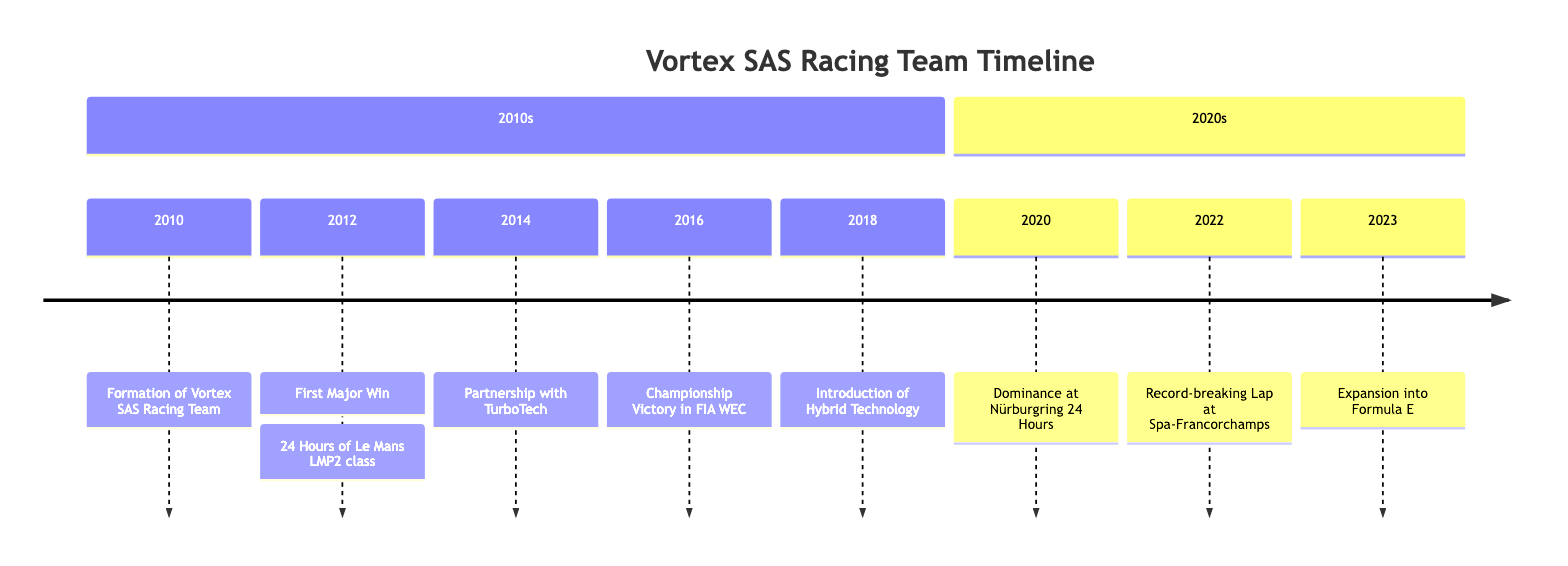What year was Vortex SAS Racing Team formed? The timeline shows the event "Formation of Vortex SAS Racing Team" listed under the year 2010, indicating that this was the year the team was founded.
Answer: 2010 What major win did Vortex SAS achieve in 2012? The timeline states that in 2012, the team secured its "First Major Win" at the "24 Hours of Le Mans in the LMP2 class." This directly identifies the event as their first victory.
Answer: 24 Hours of Le Mans LMP2 class How many major milestones are noted for the year 2016? The timeline indicates that there is one milestone listed for the year 2016, specifically the "Championship Victory in FIA WEC," which reflects a significant achievement during that year.
Answer: 1 What technology did Vortex SAS introduce in 2018? The timeline mentions "Introduction of Hybrid Technology" as the event for the year 2018, indicating that this was when the team incorporated hybrid technology into their cars.
Answer: Hybrid Technology Which year marks the dominance at the Nürburgring 24 Hours? Looking at the timeline, the event titled "Dominance at Nürburgring 24 Hours" is specifically noted under the year 2020, denoting this as the year of their significant achievement at that event.
Answer: 2020 What partnership was announced in 2014? According to the timeline, the event for 2014 is "Partnership with TurboTech," which identifies this specific partnership as a key milestone for that year.
Answer: Partnership with TurboTech Since which year has Vortex SAS expanded into Formula E? The timeline specifies that the team expanded into Formula E in the year 2023, reflecting a new direction for the team's operation in motorsport.
Answer: 2023 How many total events are listed for the 2020s? The timeline details three events in the 2020s section, which include "Dominance at Nürburgring 24 Hours" in 2020, "Record-breaking Lap at Spa-Francorchamps" in 2022, and "Expansion into Formula E" in 2023. Therefore, the total number of events is three.
Answer: 3 What was the significant achievement for Vortex SAS in 2016? The timeline specifies that 2016 marks the "Championship Victory in FIA WEC," indicating that this was a major achievement for the team during that year.
Answer: Championship Victory in FIA WEC Which year did Vortex SAS set a record-breaking lap? The timeline shows that a "Record-breaking Lap at Spa-Francorchamps" occurred in 2022, indicating the year when this significant lap time was achieved.
Answer: 2022 